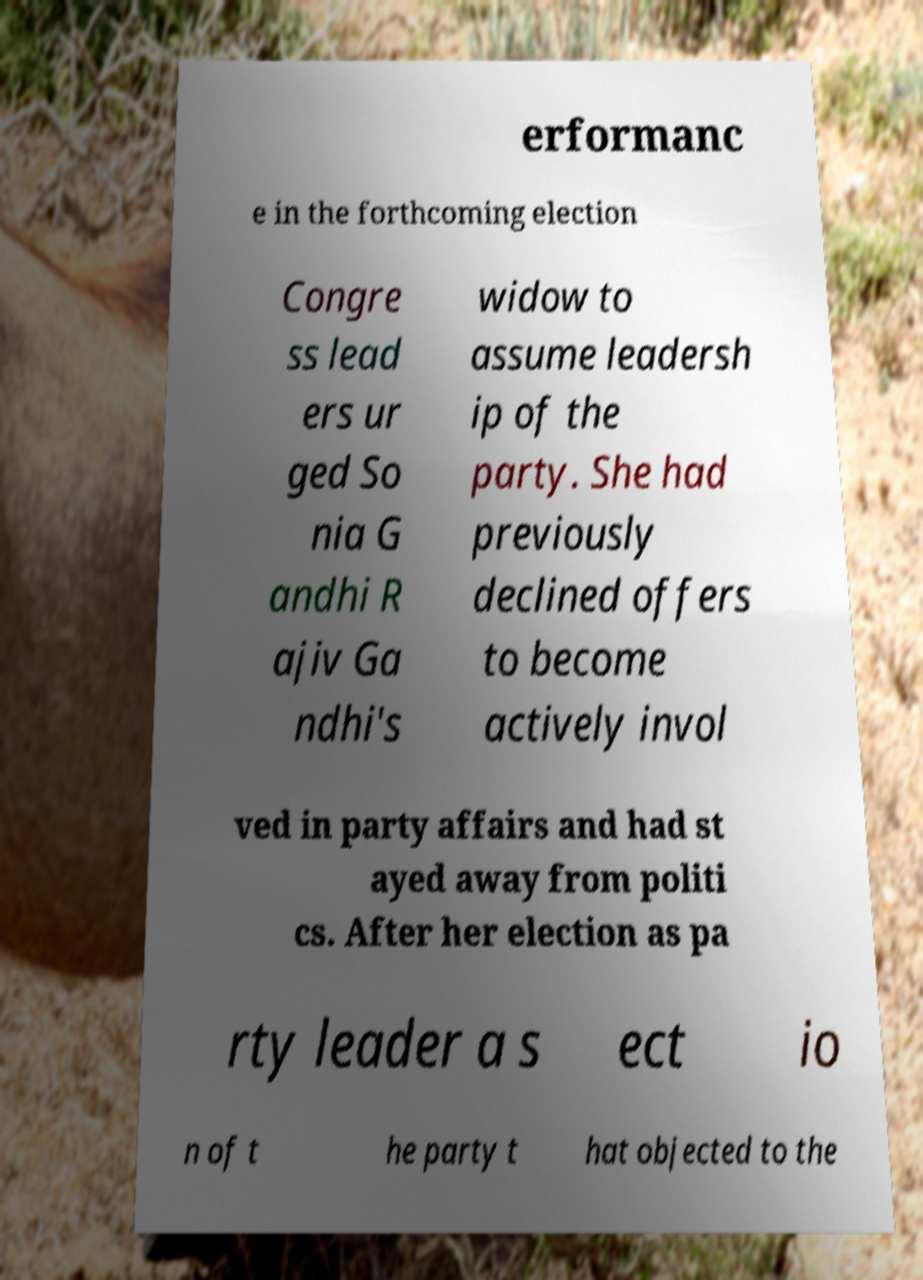Please identify and transcribe the text found in this image. erformanc e in the forthcoming election Congre ss lead ers ur ged So nia G andhi R ajiv Ga ndhi's widow to assume leadersh ip of the party. She had previously declined offers to become actively invol ved in party affairs and had st ayed away from politi cs. After her election as pa rty leader a s ect io n of t he party t hat objected to the 